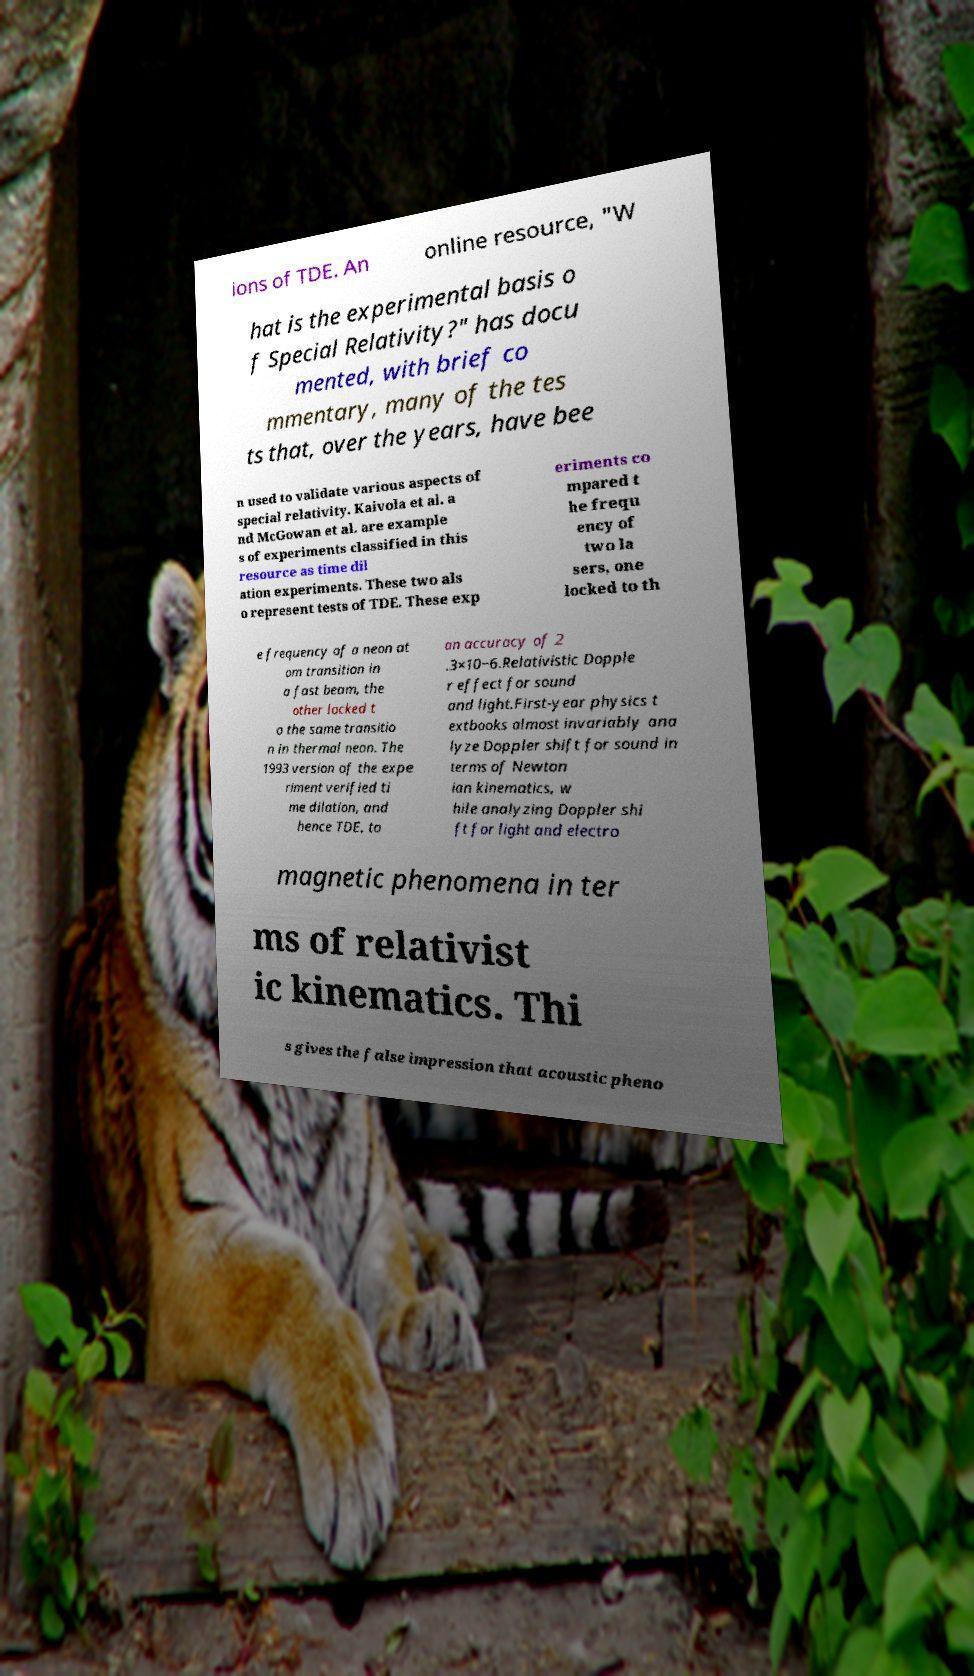Please read and relay the text visible in this image. What does it say? ions of TDE. An online resource, "W hat is the experimental basis o f Special Relativity?" has docu mented, with brief co mmentary, many of the tes ts that, over the years, have bee n used to validate various aspects of special relativity. Kaivola et al. a nd McGowan et al. are example s of experiments classified in this resource as time dil ation experiments. These two als o represent tests of TDE. These exp eriments co mpared t he frequ ency of two la sers, one locked to th e frequency of a neon at om transition in a fast beam, the other locked t o the same transitio n in thermal neon. The 1993 version of the expe riment verified ti me dilation, and hence TDE, to an accuracy of 2 .3×10−6.Relativistic Dopple r effect for sound and light.First-year physics t extbooks almost invariably ana lyze Doppler shift for sound in terms of Newton ian kinematics, w hile analyzing Doppler shi ft for light and electro magnetic phenomena in ter ms of relativist ic kinematics. Thi s gives the false impression that acoustic pheno 